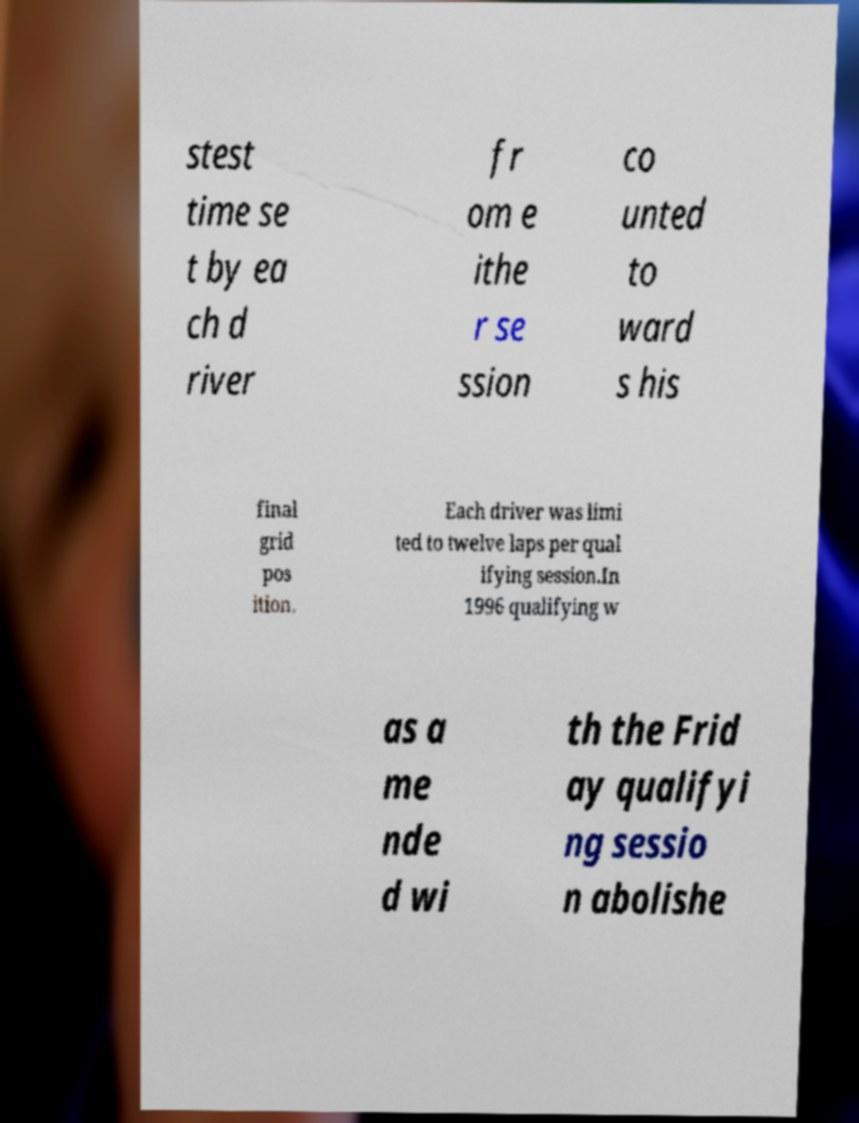For documentation purposes, I need the text within this image transcribed. Could you provide that? stest time se t by ea ch d river fr om e ithe r se ssion co unted to ward s his final grid pos ition. Each driver was limi ted to twelve laps per qual ifying session.In 1996 qualifying w as a me nde d wi th the Frid ay qualifyi ng sessio n abolishe 